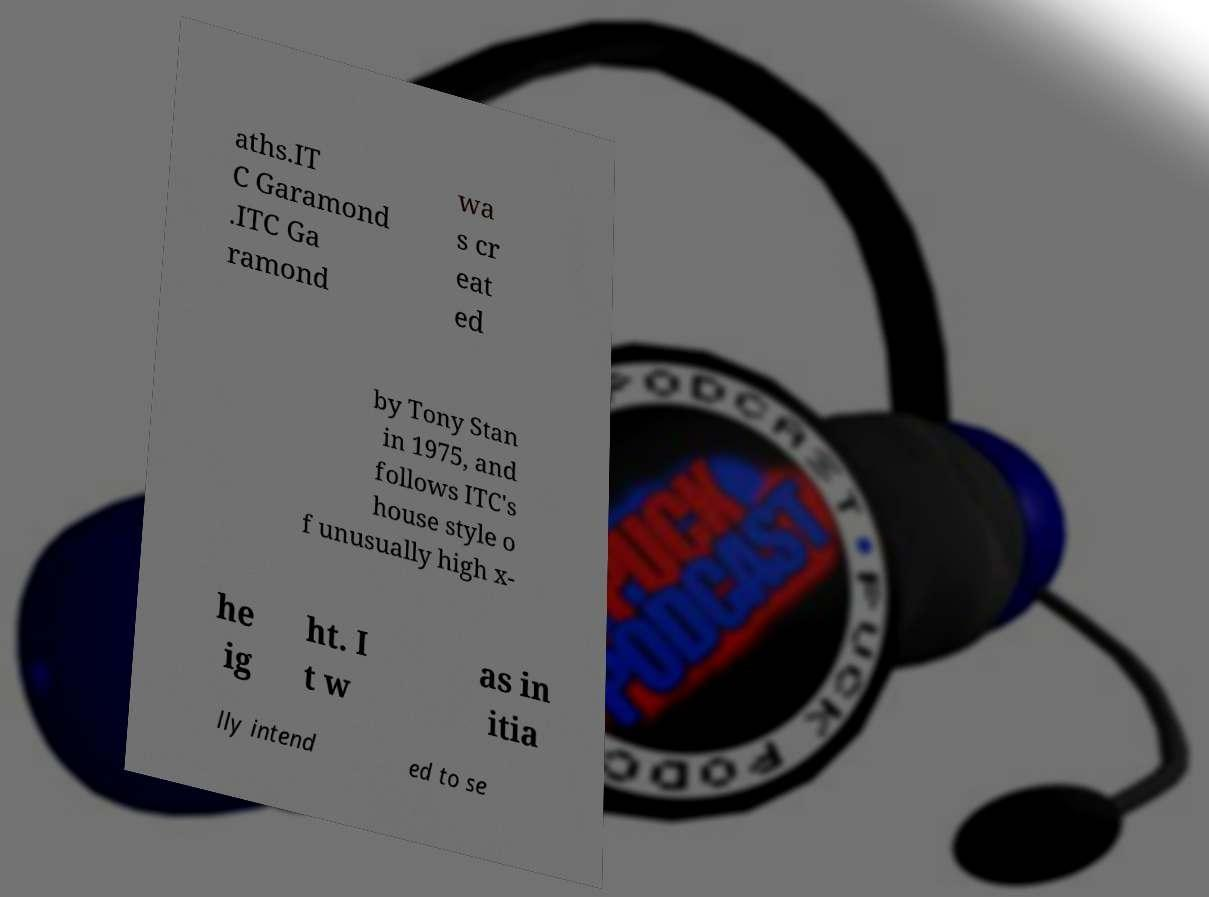For documentation purposes, I need the text within this image transcribed. Could you provide that? aths.IT C Garamond .ITC Ga ramond wa s cr eat ed by Tony Stan in 1975, and follows ITC's house style o f unusually high x- he ig ht. I t w as in itia lly intend ed to se 